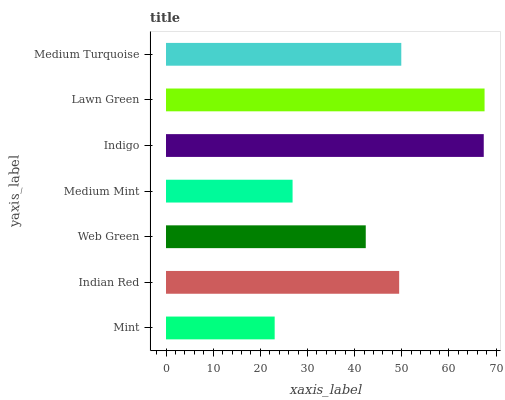Is Mint the minimum?
Answer yes or no. Yes. Is Lawn Green the maximum?
Answer yes or no. Yes. Is Indian Red the minimum?
Answer yes or no. No. Is Indian Red the maximum?
Answer yes or no. No. Is Indian Red greater than Mint?
Answer yes or no. Yes. Is Mint less than Indian Red?
Answer yes or no. Yes. Is Mint greater than Indian Red?
Answer yes or no. No. Is Indian Red less than Mint?
Answer yes or no. No. Is Indian Red the high median?
Answer yes or no. Yes. Is Indian Red the low median?
Answer yes or no. Yes. Is Web Green the high median?
Answer yes or no. No. Is Web Green the low median?
Answer yes or no. No. 